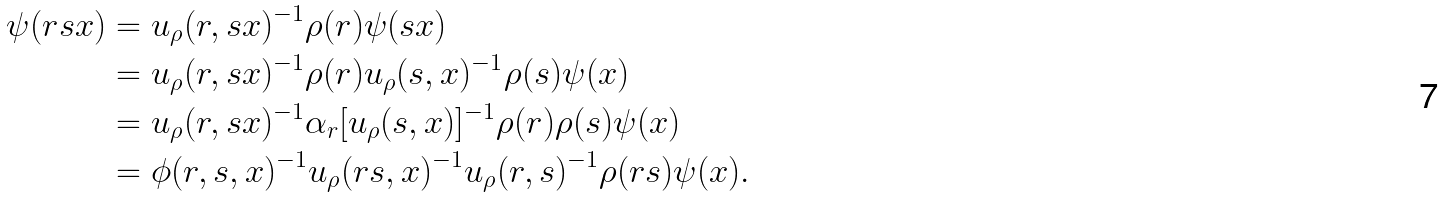<formula> <loc_0><loc_0><loc_500><loc_500>\psi ( r s x ) & = u _ { \rho } ( r , s x ) ^ { - 1 } \rho ( r ) \psi ( s x ) \\ & = u _ { \rho } ( r , s x ) ^ { - 1 } \rho ( r ) u _ { \rho } ( s , x ) ^ { - 1 } \rho ( s ) \psi ( x ) \\ & = u _ { \rho } ( r , s x ) ^ { - 1 } \alpha _ { r } [ u _ { \rho } ( s , x ) ] ^ { - 1 } \rho ( r ) \rho ( s ) \psi ( x ) \\ & = \phi ( r , s , x ) ^ { - 1 } u _ { \rho } ( r s , x ) ^ { - 1 } u _ { \rho } ( r , s ) ^ { - 1 } \rho ( r s ) \psi ( x ) .</formula> 